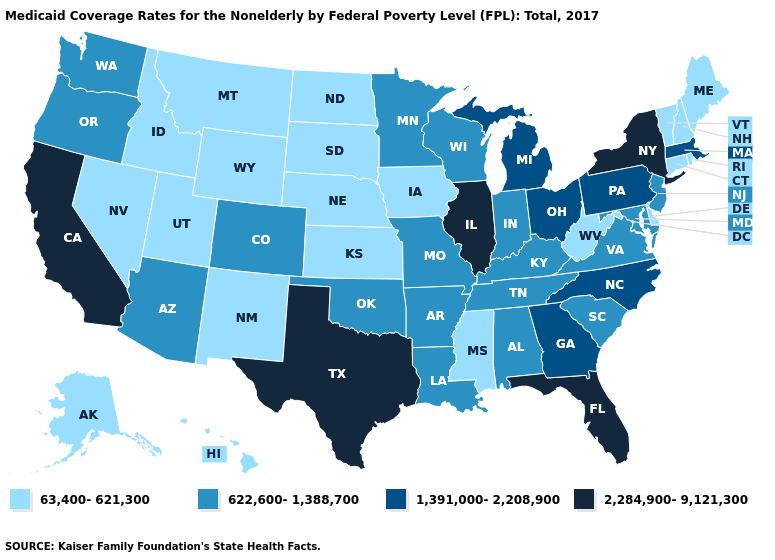How many symbols are there in the legend?
Give a very brief answer. 4. What is the value of North Carolina?
Quick response, please. 1,391,000-2,208,900. What is the value of Hawaii?
Answer briefly. 63,400-621,300. What is the highest value in the USA?
Keep it brief. 2,284,900-9,121,300. Does Texas have the highest value in the USA?
Keep it brief. Yes. Name the states that have a value in the range 622,600-1,388,700?
Keep it brief. Alabama, Arizona, Arkansas, Colorado, Indiana, Kentucky, Louisiana, Maryland, Minnesota, Missouri, New Jersey, Oklahoma, Oregon, South Carolina, Tennessee, Virginia, Washington, Wisconsin. Name the states that have a value in the range 1,391,000-2,208,900?
Concise answer only. Georgia, Massachusetts, Michigan, North Carolina, Ohio, Pennsylvania. What is the value of South Carolina?
Keep it brief. 622,600-1,388,700. Which states hav the highest value in the West?
Concise answer only. California. What is the lowest value in the Northeast?
Quick response, please. 63,400-621,300. Among the states that border California , does Nevada have the highest value?
Give a very brief answer. No. What is the value of Minnesota?
Keep it brief. 622,600-1,388,700. What is the lowest value in the South?
Quick response, please. 63,400-621,300. Name the states that have a value in the range 2,284,900-9,121,300?
Write a very short answer. California, Florida, Illinois, New York, Texas. Does the map have missing data?
Short answer required. No. 